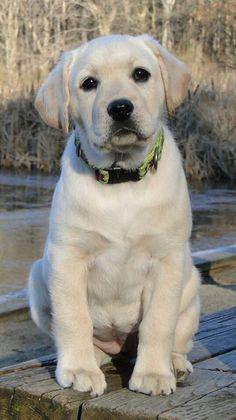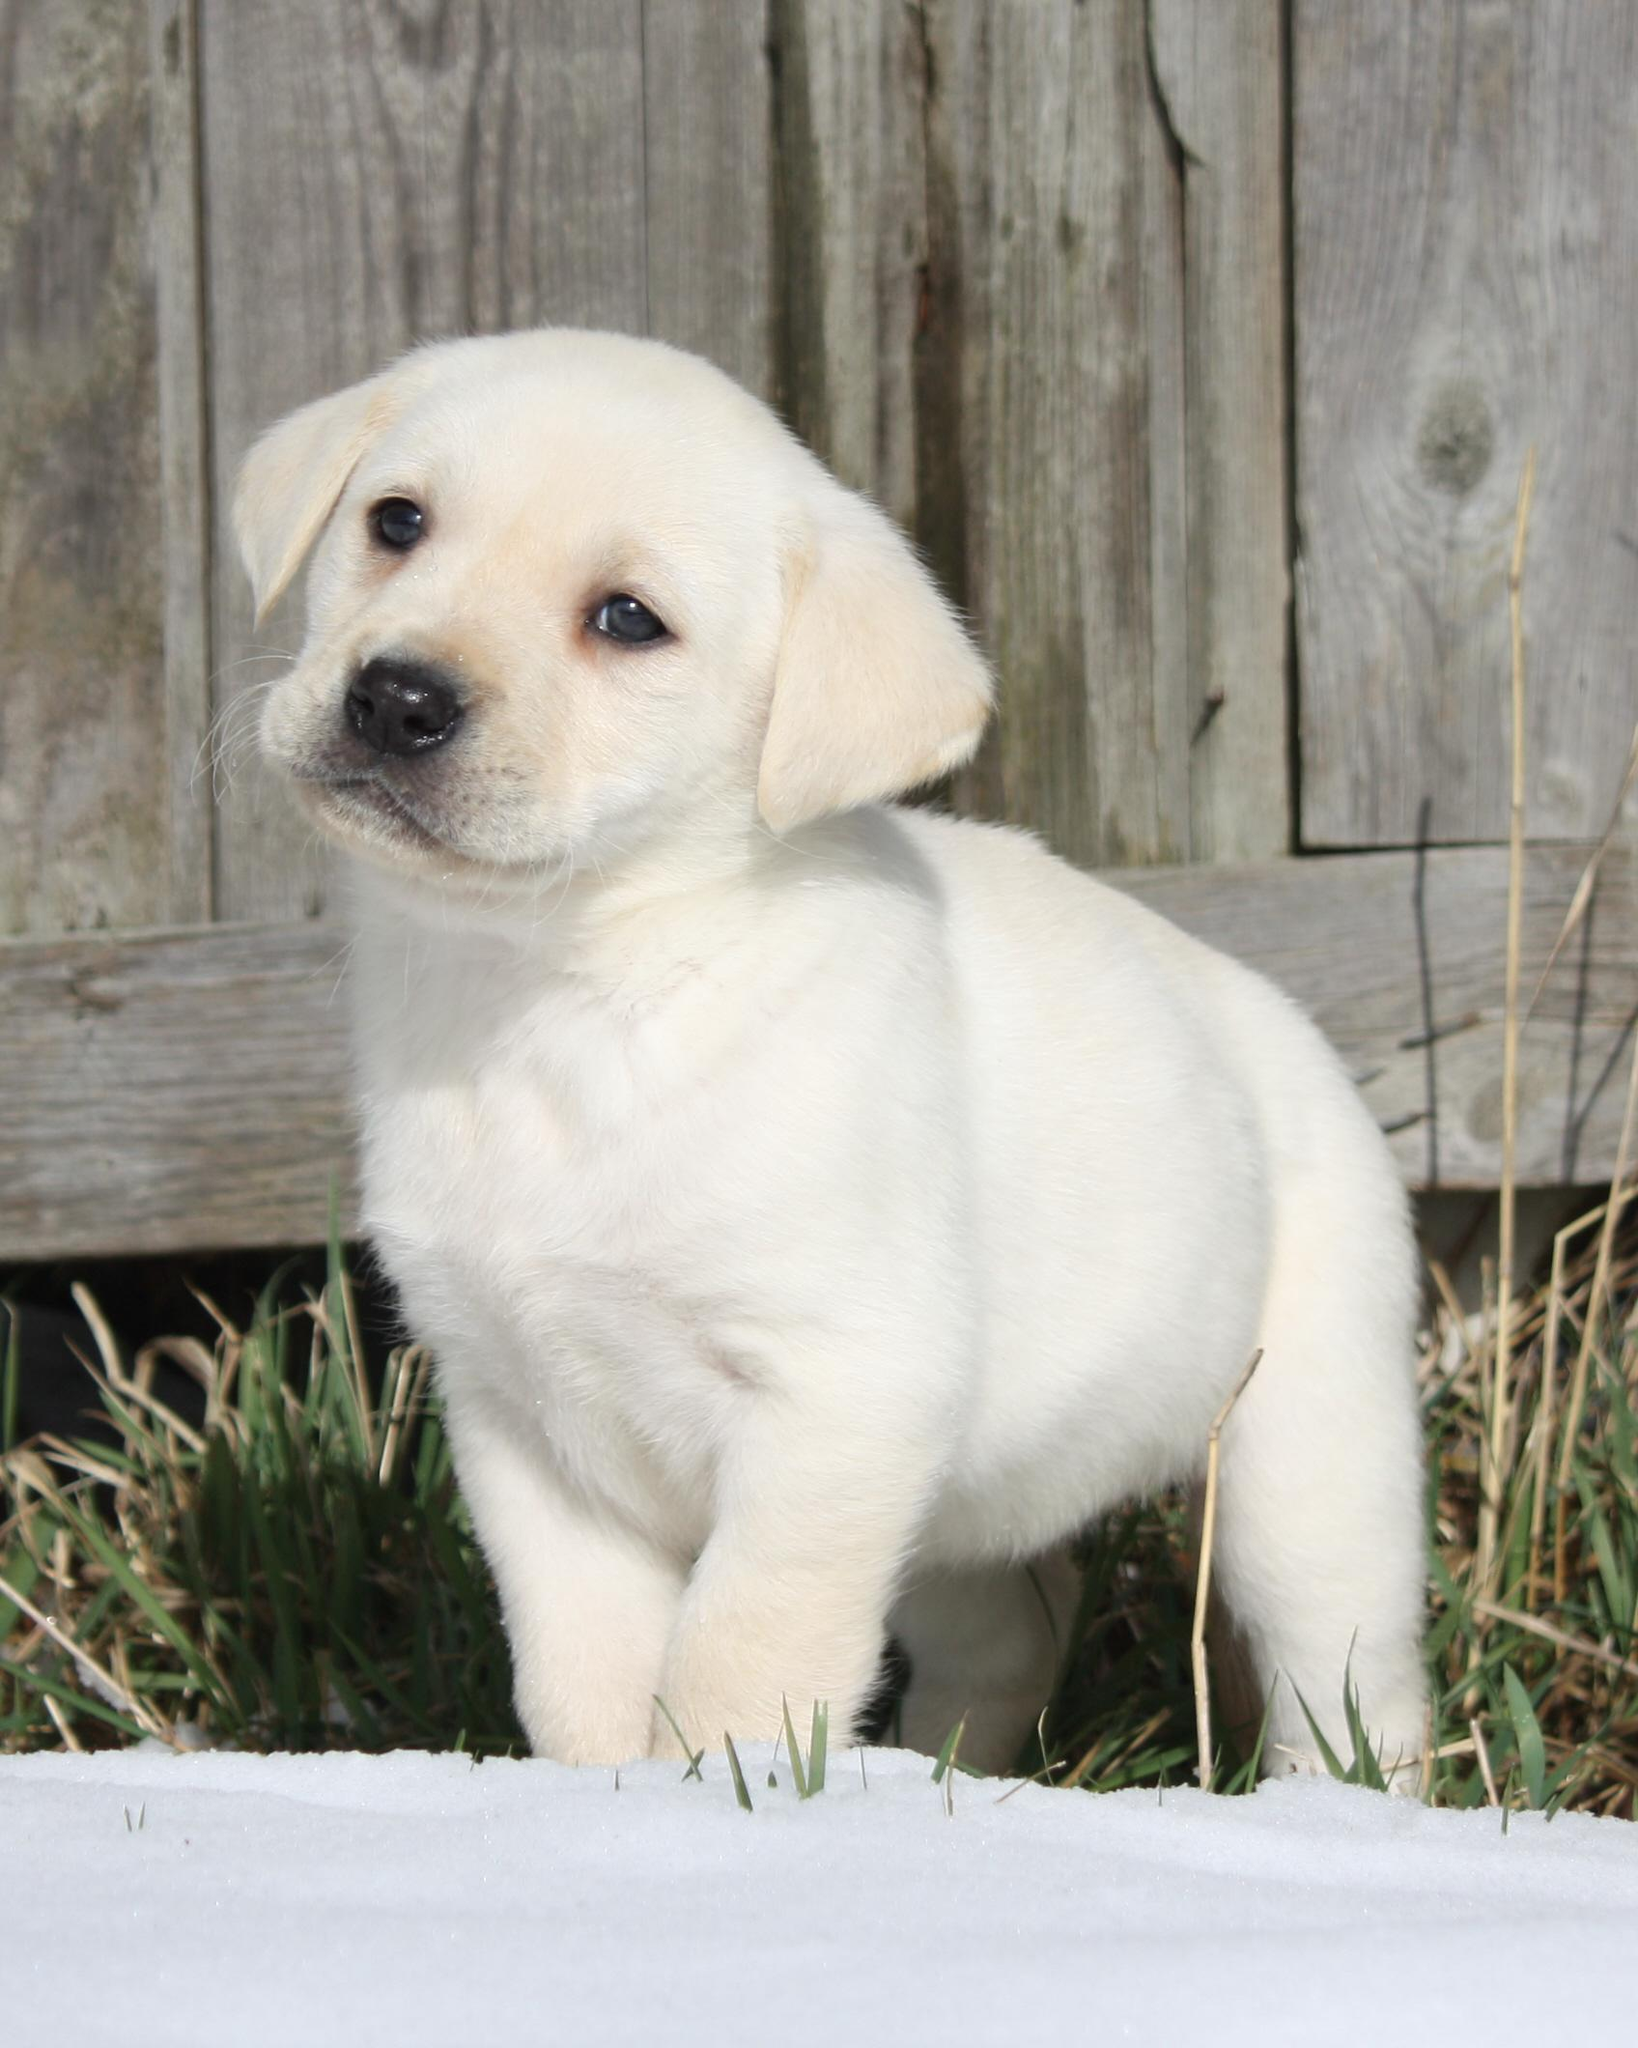The first image is the image on the left, the second image is the image on the right. Considering the images on both sides, is "No puppy is standing, and exactly one puppy is reclining with front paws extended in front of its body." valid? Answer yes or no. No. The first image is the image on the left, the second image is the image on the right. Examine the images to the left and right. Is the description "One dog has a toy." accurate? Answer yes or no. No. 